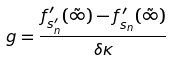<formula> <loc_0><loc_0><loc_500><loc_500>g = \frac { f ^ { \prime } _ { s ^ { \prime } _ { n } } ( \tilde { \infty } ) - f ^ { \prime } _ { s _ { n } } ( \tilde { \infty } ) } { \delta \kappa }</formula> 